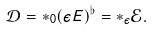Convert formula to latex. <formula><loc_0><loc_0><loc_500><loc_500>\mathcal { D } = * _ { 0 } ( \epsilon E ) ^ { \flat } = * _ { \epsilon } \mathcal { E } .</formula> 